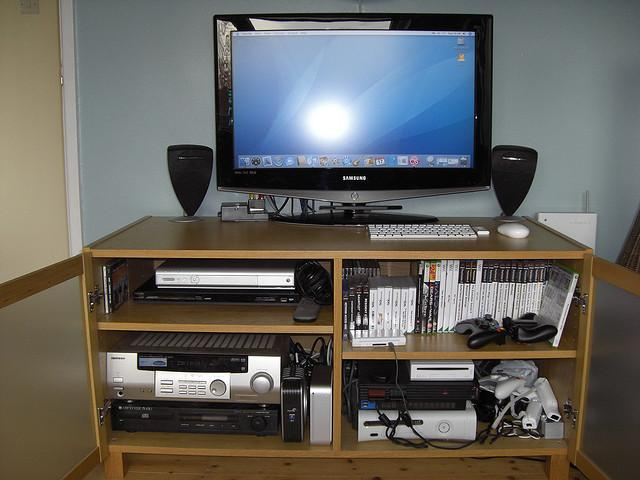What is the purpose of this setup? Please explain your reasoning. entertainment. A television is on a stand with a computer keyboard. 